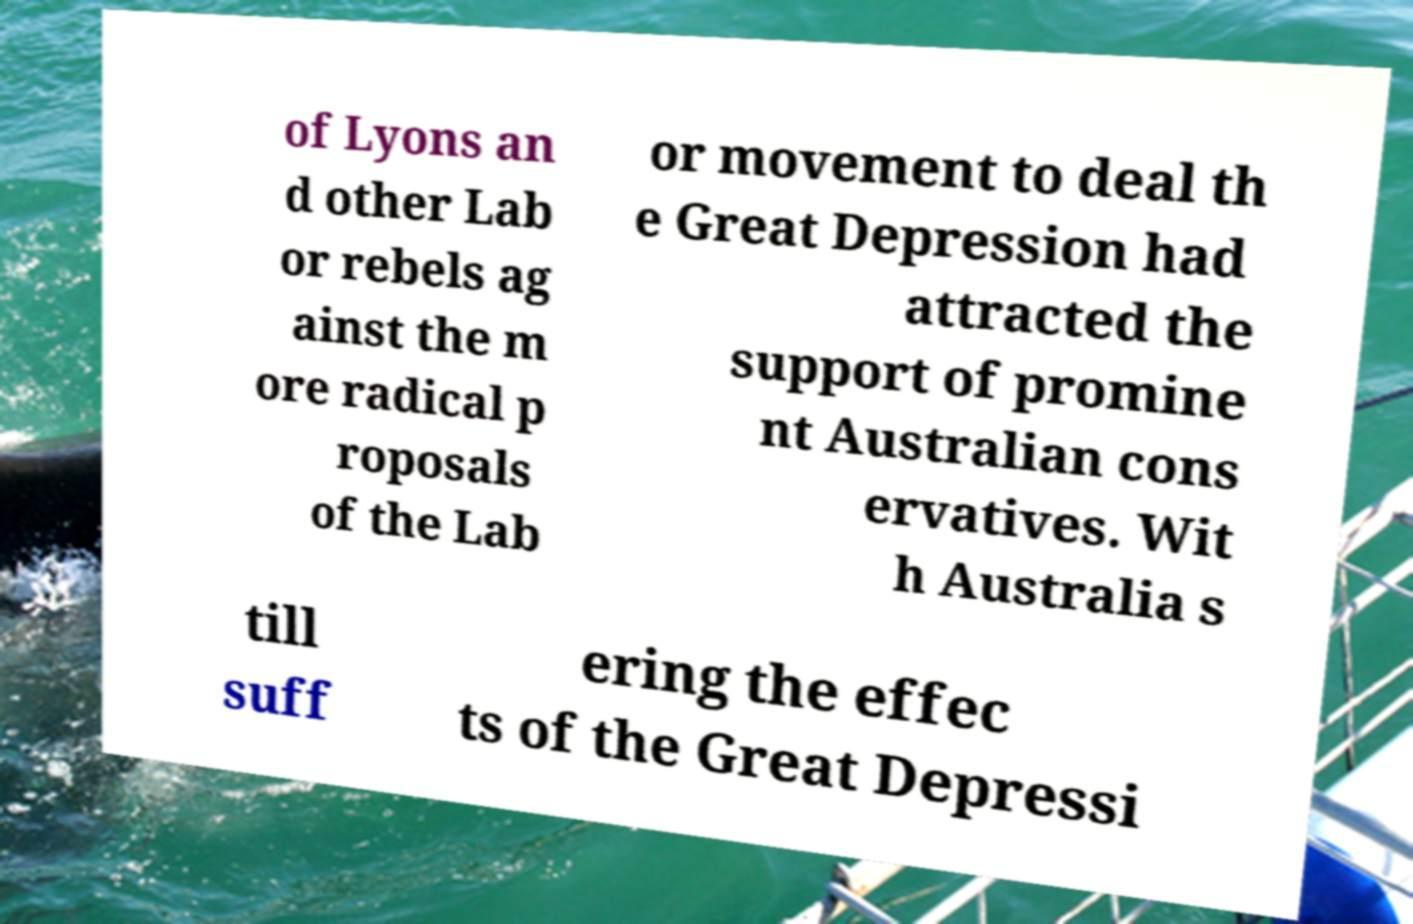Could you extract and type out the text from this image? of Lyons an d other Lab or rebels ag ainst the m ore radical p roposals of the Lab or movement to deal th e Great Depression had attracted the support of promine nt Australian cons ervatives. Wit h Australia s till suff ering the effec ts of the Great Depressi 